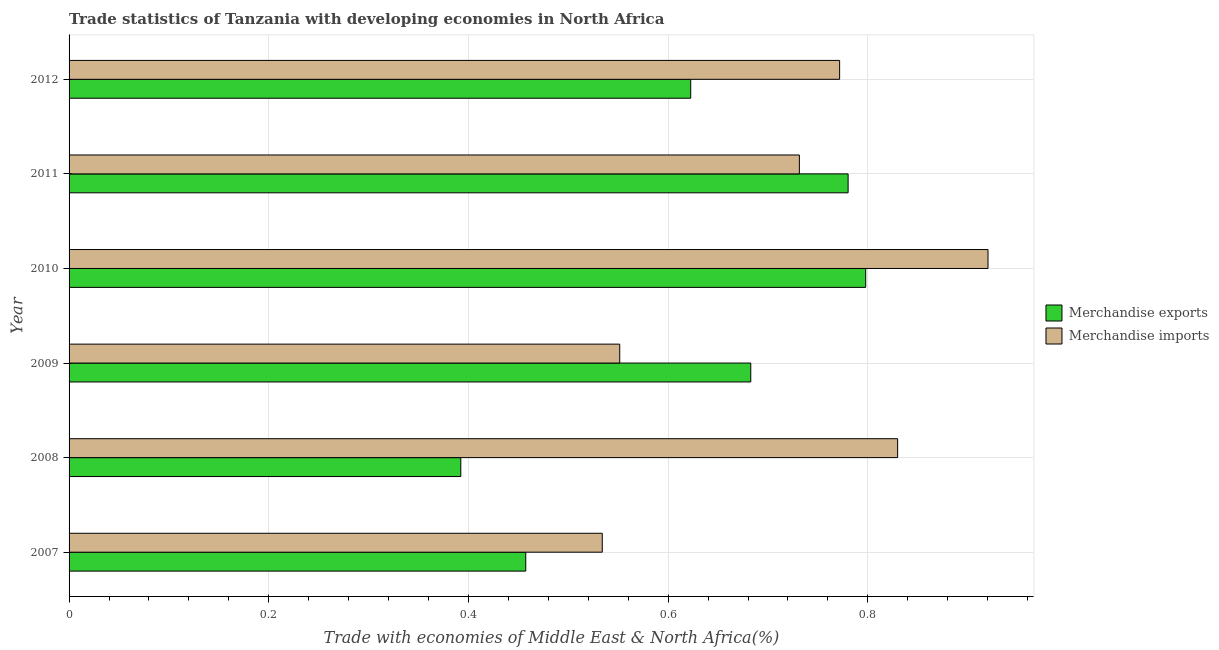How many different coloured bars are there?
Your answer should be compact. 2. How many bars are there on the 3rd tick from the top?
Your answer should be very brief. 2. What is the merchandise imports in 2011?
Make the answer very short. 0.73. Across all years, what is the maximum merchandise imports?
Make the answer very short. 0.92. Across all years, what is the minimum merchandise imports?
Your answer should be very brief. 0.53. In which year was the merchandise exports maximum?
Your answer should be very brief. 2010. What is the total merchandise imports in the graph?
Offer a very short reply. 4.34. What is the difference between the merchandise imports in 2008 and the merchandise exports in 2012?
Give a very brief answer. 0.21. What is the average merchandise imports per year?
Your answer should be compact. 0.72. In the year 2009, what is the difference between the merchandise exports and merchandise imports?
Give a very brief answer. 0.13. In how many years, is the merchandise exports greater than 0.44 %?
Make the answer very short. 5. What is the ratio of the merchandise exports in 2007 to that in 2012?
Make the answer very short. 0.73. Is the difference between the merchandise exports in 2008 and 2011 greater than the difference between the merchandise imports in 2008 and 2011?
Ensure brevity in your answer.  No. What is the difference between the highest and the second highest merchandise exports?
Make the answer very short. 0.02. What is the difference between the highest and the lowest merchandise exports?
Make the answer very short. 0.41. Is the sum of the merchandise exports in 2009 and 2011 greater than the maximum merchandise imports across all years?
Keep it short and to the point. Yes. What does the 1st bar from the bottom in 2007 represents?
Give a very brief answer. Merchandise exports. What is the difference between two consecutive major ticks on the X-axis?
Offer a terse response. 0.2. Are the values on the major ticks of X-axis written in scientific E-notation?
Make the answer very short. No. Does the graph contain any zero values?
Your response must be concise. No. Does the graph contain grids?
Keep it short and to the point. Yes. Where does the legend appear in the graph?
Your answer should be compact. Center right. How many legend labels are there?
Make the answer very short. 2. How are the legend labels stacked?
Provide a short and direct response. Vertical. What is the title of the graph?
Your answer should be compact. Trade statistics of Tanzania with developing economies in North Africa. What is the label or title of the X-axis?
Provide a short and direct response. Trade with economies of Middle East & North Africa(%). What is the label or title of the Y-axis?
Your answer should be very brief. Year. What is the Trade with economies of Middle East & North Africa(%) in Merchandise exports in 2007?
Your answer should be compact. 0.46. What is the Trade with economies of Middle East & North Africa(%) in Merchandise imports in 2007?
Your response must be concise. 0.53. What is the Trade with economies of Middle East & North Africa(%) of Merchandise exports in 2008?
Your answer should be very brief. 0.39. What is the Trade with economies of Middle East & North Africa(%) in Merchandise imports in 2008?
Your answer should be very brief. 0.83. What is the Trade with economies of Middle East & North Africa(%) of Merchandise exports in 2009?
Your answer should be compact. 0.68. What is the Trade with economies of Middle East & North Africa(%) of Merchandise imports in 2009?
Offer a terse response. 0.55. What is the Trade with economies of Middle East & North Africa(%) in Merchandise exports in 2010?
Ensure brevity in your answer.  0.8. What is the Trade with economies of Middle East & North Africa(%) of Merchandise imports in 2010?
Provide a succinct answer. 0.92. What is the Trade with economies of Middle East & North Africa(%) of Merchandise exports in 2011?
Your answer should be very brief. 0.78. What is the Trade with economies of Middle East & North Africa(%) in Merchandise imports in 2011?
Provide a short and direct response. 0.73. What is the Trade with economies of Middle East & North Africa(%) in Merchandise exports in 2012?
Your response must be concise. 0.62. What is the Trade with economies of Middle East & North Africa(%) of Merchandise imports in 2012?
Your answer should be compact. 0.77. Across all years, what is the maximum Trade with economies of Middle East & North Africa(%) of Merchandise exports?
Provide a succinct answer. 0.8. Across all years, what is the maximum Trade with economies of Middle East & North Africa(%) in Merchandise imports?
Keep it short and to the point. 0.92. Across all years, what is the minimum Trade with economies of Middle East & North Africa(%) in Merchandise exports?
Keep it short and to the point. 0.39. Across all years, what is the minimum Trade with economies of Middle East & North Africa(%) of Merchandise imports?
Ensure brevity in your answer.  0.53. What is the total Trade with economies of Middle East & North Africa(%) of Merchandise exports in the graph?
Your response must be concise. 3.73. What is the total Trade with economies of Middle East & North Africa(%) in Merchandise imports in the graph?
Make the answer very short. 4.34. What is the difference between the Trade with economies of Middle East & North Africa(%) in Merchandise exports in 2007 and that in 2008?
Provide a succinct answer. 0.07. What is the difference between the Trade with economies of Middle East & North Africa(%) of Merchandise imports in 2007 and that in 2008?
Provide a short and direct response. -0.3. What is the difference between the Trade with economies of Middle East & North Africa(%) of Merchandise exports in 2007 and that in 2009?
Give a very brief answer. -0.23. What is the difference between the Trade with economies of Middle East & North Africa(%) of Merchandise imports in 2007 and that in 2009?
Offer a terse response. -0.02. What is the difference between the Trade with economies of Middle East & North Africa(%) of Merchandise exports in 2007 and that in 2010?
Your answer should be very brief. -0.34. What is the difference between the Trade with economies of Middle East & North Africa(%) of Merchandise imports in 2007 and that in 2010?
Provide a short and direct response. -0.39. What is the difference between the Trade with economies of Middle East & North Africa(%) of Merchandise exports in 2007 and that in 2011?
Ensure brevity in your answer.  -0.32. What is the difference between the Trade with economies of Middle East & North Africa(%) of Merchandise imports in 2007 and that in 2011?
Offer a very short reply. -0.2. What is the difference between the Trade with economies of Middle East & North Africa(%) of Merchandise exports in 2007 and that in 2012?
Make the answer very short. -0.17. What is the difference between the Trade with economies of Middle East & North Africa(%) of Merchandise imports in 2007 and that in 2012?
Offer a very short reply. -0.24. What is the difference between the Trade with economies of Middle East & North Africa(%) in Merchandise exports in 2008 and that in 2009?
Your response must be concise. -0.29. What is the difference between the Trade with economies of Middle East & North Africa(%) in Merchandise imports in 2008 and that in 2009?
Your answer should be compact. 0.28. What is the difference between the Trade with economies of Middle East & North Africa(%) of Merchandise exports in 2008 and that in 2010?
Make the answer very short. -0.41. What is the difference between the Trade with economies of Middle East & North Africa(%) of Merchandise imports in 2008 and that in 2010?
Offer a very short reply. -0.09. What is the difference between the Trade with economies of Middle East & North Africa(%) in Merchandise exports in 2008 and that in 2011?
Keep it short and to the point. -0.39. What is the difference between the Trade with economies of Middle East & North Africa(%) in Merchandise imports in 2008 and that in 2011?
Keep it short and to the point. 0.1. What is the difference between the Trade with economies of Middle East & North Africa(%) of Merchandise exports in 2008 and that in 2012?
Give a very brief answer. -0.23. What is the difference between the Trade with economies of Middle East & North Africa(%) of Merchandise imports in 2008 and that in 2012?
Give a very brief answer. 0.06. What is the difference between the Trade with economies of Middle East & North Africa(%) of Merchandise exports in 2009 and that in 2010?
Offer a terse response. -0.12. What is the difference between the Trade with economies of Middle East & North Africa(%) in Merchandise imports in 2009 and that in 2010?
Your answer should be very brief. -0.37. What is the difference between the Trade with economies of Middle East & North Africa(%) of Merchandise exports in 2009 and that in 2011?
Offer a terse response. -0.1. What is the difference between the Trade with economies of Middle East & North Africa(%) in Merchandise imports in 2009 and that in 2011?
Ensure brevity in your answer.  -0.18. What is the difference between the Trade with economies of Middle East & North Africa(%) of Merchandise exports in 2009 and that in 2012?
Provide a succinct answer. 0.06. What is the difference between the Trade with economies of Middle East & North Africa(%) of Merchandise imports in 2009 and that in 2012?
Make the answer very short. -0.22. What is the difference between the Trade with economies of Middle East & North Africa(%) of Merchandise exports in 2010 and that in 2011?
Ensure brevity in your answer.  0.02. What is the difference between the Trade with economies of Middle East & North Africa(%) in Merchandise imports in 2010 and that in 2011?
Ensure brevity in your answer.  0.19. What is the difference between the Trade with economies of Middle East & North Africa(%) in Merchandise exports in 2010 and that in 2012?
Your answer should be compact. 0.18. What is the difference between the Trade with economies of Middle East & North Africa(%) of Merchandise imports in 2010 and that in 2012?
Provide a succinct answer. 0.15. What is the difference between the Trade with economies of Middle East & North Africa(%) of Merchandise exports in 2011 and that in 2012?
Offer a terse response. 0.16. What is the difference between the Trade with economies of Middle East & North Africa(%) in Merchandise imports in 2011 and that in 2012?
Keep it short and to the point. -0.04. What is the difference between the Trade with economies of Middle East & North Africa(%) in Merchandise exports in 2007 and the Trade with economies of Middle East & North Africa(%) in Merchandise imports in 2008?
Provide a short and direct response. -0.37. What is the difference between the Trade with economies of Middle East & North Africa(%) in Merchandise exports in 2007 and the Trade with economies of Middle East & North Africa(%) in Merchandise imports in 2009?
Make the answer very short. -0.09. What is the difference between the Trade with economies of Middle East & North Africa(%) of Merchandise exports in 2007 and the Trade with economies of Middle East & North Africa(%) of Merchandise imports in 2010?
Give a very brief answer. -0.46. What is the difference between the Trade with economies of Middle East & North Africa(%) in Merchandise exports in 2007 and the Trade with economies of Middle East & North Africa(%) in Merchandise imports in 2011?
Your response must be concise. -0.27. What is the difference between the Trade with economies of Middle East & North Africa(%) of Merchandise exports in 2007 and the Trade with economies of Middle East & North Africa(%) of Merchandise imports in 2012?
Your answer should be compact. -0.31. What is the difference between the Trade with economies of Middle East & North Africa(%) in Merchandise exports in 2008 and the Trade with economies of Middle East & North Africa(%) in Merchandise imports in 2009?
Give a very brief answer. -0.16. What is the difference between the Trade with economies of Middle East & North Africa(%) of Merchandise exports in 2008 and the Trade with economies of Middle East & North Africa(%) of Merchandise imports in 2010?
Give a very brief answer. -0.53. What is the difference between the Trade with economies of Middle East & North Africa(%) of Merchandise exports in 2008 and the Trade with economies of Middle East & North Africa(%) of Merchandise imports in 2011?
Keep it short and to the point. -0.34. What is the difference between the Trade with economies of Middle East & North Africa(%) in Merchandise exports in 2008 and the Trade with economies of Middle East & North Africa(%) in Merchandise imports in 2012?
Your answer should be very brief. -0.38. What is the difference between the Trade with economies of Middle East & North Africa(%) of Merchandise exports in 2009 and the Trade with economies of Middle East & North Africa(%) of Merchandise imports in 2010?
Offer a terse response. -0.24. What is the difference between the Trade with economies of Middle East & North Africa(%) of Merchandise exports in 2009 and the Trade with economies of Middle East & North Africa(%) of Merchandise imports in 2011?
Your answer should be compact. -0.05. What is the difference between the Trade with economies of Middle East & North Africa(%) of Merchandise exports in 2009 and the Trade with economies of Middle East & North Africa(%) of Merchandise imports in 2012?
Provide a succinct answer. -0.09. What is the difference between the Trade with economies of Middle East & North Africa(%) in Merchandise exports in 2010 and the Trade with economies of Middle East & North Africa(%) in Merchandise imports in 2011?
Provide a short and direct response. 0.07. What is the difference between the Trade with economies of Middle East & North Africa(%) in Merchandise exports in 2010 and the Trade with economies of Middle East & North Africa(%) in Merchandise imports in 2012?
Your answer should be very brief. 0.03. What is the difference between the Trade with economies of Middle East & North Africa(%) in Merchandise exports in 2011 and the Trade with economies of Middle East & North Africa(%) in Merchandise imports in 2012?
Offer a very short reply. 0.01. What is the average Trade with economies of Middle East & North Africa(%) of Merchandise exports per year?
Offer a very short reply. 0.62. What is the average Trade with economies of Middle East & North Africa(%) of Merchandise imports per year?
Keep it short and to the point. 0.72. In the year 2007, what is the difference between the Trade with economies of Middle East & North Africa(%) in Merchandise exports and Trade with economies of Middle East & North Africa(%) in Merchandise imports?
Keep it short and to the point. -0.08. In the year 2008, what is the difference between the Trade with economies of Middle East & North Africa(%) in Merchandise exports and Trade with economies of Middle East & North Africa(%) in Merchandise imports?
Keep it short and to the point. -0.44. In the year 2009, what is the difference between the Trade with economies of Middle East & North Africa(%) of Merchandise exports and Trade with economies of Middle East & North Africa(%) of Merchandise imports?
Your response must be concise. 0.13. In the year 2010, what is the difference between the Trade with economies of Middle East & North Africa(%) in Merchandise exports and Trade with economies of Middle East & North Africa(%) in Merchandise imports?
Make the answer very short. -0.12. In the year 2011, what is the difference between the Trade with economies of Middle East & North Africa(%) of Merchandise exports and Trade with economies of Middle East & North Africa(%) of Merchandise imports?
Offer a very short reply. 0.05. In the year 2012, what is the difference between the Trade with economies of Middle East & North Africa(%) in Merchandise exports and Trade with economies of Middle East & North Africa(%) in Merchandise imports?
Provide a succinct answer. -0.15. What is the ratio of the Trade with economies of Middle East & North Africa(%) in Merchandise exports in 2007 to that in 2008?
Provide a short and direct response. 1.17. What is the ratio of the Trade with economies of Middle East & North Africa(%) in Merchandise imports in 2007 to that in 2008?
Your response must be concise. 0.64. What is the ratio of the Trade with economies of Middle East & North Africa(%) of Merchandise exports in 2007 to that in 2009?
Give a very brief answer. 0.67. What is the ratio of the Trade with economies of Middle East & North Africa(%) of Merchandise imports in 2007 to that in 2009?
Ensure brevity in your answer.  0.97. What is the ratio of the Trade with economies of Middle East & North Africa(%) of Merchandise exports in 2007 to that in 2010?
Your response must be concise. 0.57. What is the ratio of the Trade with economies of Middle East & North Africa(%) of Merchandise imports in 2007 to that in 2010?
Offer a very short reply. 0.58. What is the ratio of the Trade with economies of Middle East & North Africa(%) in Merchandise exports in 2007 to that in 2011?
Ensure brevity in your answer.  0.59. What is the ratio of the Trade with economies of Middle East & North Africa(%) in Merchandise imports in 2007 to that in 2011?
Offer a terse response. 0.73. What is the ratio of the Trade with economies of Middle East & North Africa(%) of Merchandise exports in 2007 to that in 2012?
Offer a very short reply. 0.73. What is the ratio of the Trade with economies of Middle East & North Africa(%) in Merchandise imports in 2007 to that in 2012?
Your answer should be compact. 0.69. What is the ratio of the Trade with economies of Middle East & North Africa(%) of Merchandise exports in 2008 to that in 2009?
Give a very brief answer. 0.57. What is the ratio of the Trade with economies of Middle East & North Africa(%) in Merchandise imports in 2008 to that in 2009?
Give a very brief answer. 1.5. What is the ratio of the Trade with economies of Middle East & North Africa(%) of Merchandise exports in 2008 to that in 2010?
Keep it short and to the point. 0.49. What is the ratio of the Trade with economies of Middle East & North Africa(%) of Merchandise imports in 2008 to that in 2010?
Ensure brevity in your answer.  0.9. What is the ratio of the Trade with economies of Middle East & North Africa(%) of Merchandise exports in 2008 to that in 2011?
Give a very brief answer. 0.5. What is the ratio of the Trade with economies of Middle East & North Africa(%) in Merchandise imports in 2008 to that in 2011?
Provide a succinct answer. 1.13. What is the ratio of the Trade with economies of Middle East & North Africa(%) of Merchandise exports in 2008 to that in 2012?
Provide a short and direct response. 0.63. What is the ratio of the Trade with economies of Middle East & North Africa(%) of Merchandise imports in 2008 to that in 2012?
Give a very brief answer. 1.08. What is the ratio of the Trade with economies of Middle East & North Africa(%) in Merchandise exports in 2009 to that in 2010?
Your response must be concise. 0.86. What is the ratio of the Trade with economies of Middle East & North Africa(%) in Merchandise imports in 2009 to that in 2010?
Provide a succinct answer. 0.6. What is the ratio of the Trade with economies of Middle East & North Africa(%) of Merchandise exports in 2009 to that in 2011?
Offer a terse response. 0.88. What is the ratio of the Trade with economies of Middle East & North Africa(%) in Merchandise imports in 2009 to that in 2011?
Your answer should be compact. 0.75. What is the ratio of the Trade with economies of Middle East & North Africa(%) in Merchandise exports in 2009 to that in 2012?
Provide a succinct answer. 1.1. What is the ratio of the Trade with economies of Middle East & North Africa(%) in Merchandise imports in 2009 to that in 2012?
Offer a terse response. 0.71. What is the ratio of the Trade with economies of Middle East & North Africa(%) of Merchandise exports in 2010 to that in 2011?
Your answer should be compact. 1.02. What is the ratio of the Trade with economies of Middle East & North Africa(%) of Merchandise imports in 2010 to that in 2011?
Ensure brevity in your answer.  1.26. What is the ratio of the Trade with economies of Middle East & North Africa(%) of Merchandise exports in 2010 to that in 2012?
Ensure brevity in your answer.  1.28. What is the ratio of the Trade with economies of Middle East & North Africa(%) of Merchandise imports in 2010 to that in 2012?
Give a very brief answer. 1.19. What is the ratio of the Trade with economies of Middle East & North Africa(%) in Merchandise exports in 2011 to that in 2012?
Your response must be concise. 1.25. What is the ratio of the Trade with economies of Middle East & North Africa(%) in Merchandise imports in 2011 to that in 2012?
Ensure brevity in your answer.  0.95. What is the difference between the highest and the second highest Trade with economies of Middle East & North Africa(%) in Merchandise exports?
Provide a succinct answer. 0.02. What is the difference between the highest and the second highest Trade with economies of Middle East & North Africa(%) in Merchandise imports?
Keep it short and to the point. 0.09. What is the difference between the highest and the lowest Trade with economies of Middle East & North Africa(%) in Merchandise exports?
Ensure brevity in your answer.  0.41. What is the difference between the highest and the lowest Trade with economies of Middle East & North Africa(%) of Merchandise imports?
Keep it short and to the point. 0.39. 